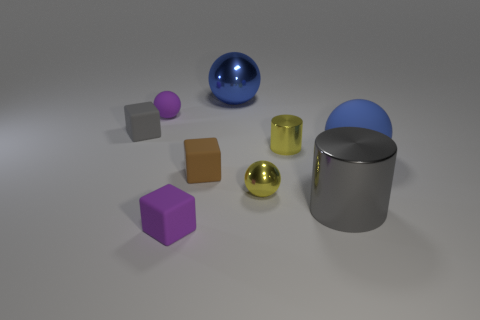There is a matte object that is in front of the brown rubber cube; is its color the same as the big metallic sphere?
Provide a short and direct response. No. There is a small purple rubber object behind the tiny brown rubber cube; how many large things are behind it?
Offer a terse response. 1. What is the color of the metallic thing that is the same size as the gray metallic cylinder?
Make the answer very short. Blue. What is the tiny ball that is on the left side of the tiny brown thing made of?
Your answer should be compact. Rubber. There is a small cube that is both in front of the blue rubber ball and behind the large gray object; what is its material?
Offer a very short reply. Rubber. There is a matte thing that is behind the gray matte block; is its size the same as the yellow ball?
Provide a short and direct response. Yes. There is a brown object; what shape is it?
Your response must be concise. Cube. What number of tiny brown rubber things have the same shape as the blue matte object?
Offer a terse response. 0. What number of balls are both behind the gray matte thing and to the right of the tiny brown rubber object?
Provide a short and direct response. 1. The big cylinder is what color?
Ensure brevity in your answer.  Gray. 